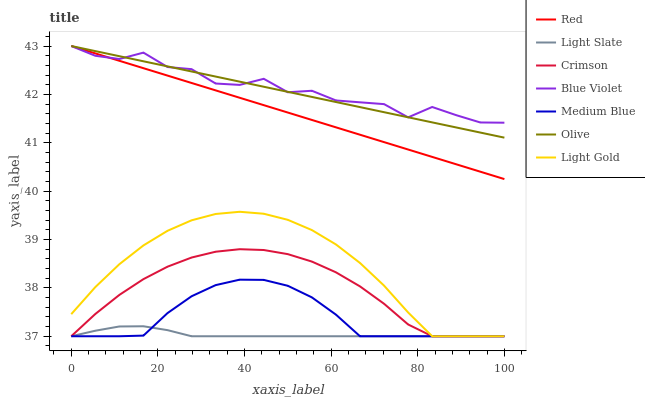Does Light Slate have the minimum area under the curve?
Answer yes or no. Yes. Does Blue Violet have the maximum area under the curve?
Answer yes or no. Yes. Does Medium Blue have the minimum area under the curve?
Answer yes or no. No. Does Medium Blue have the maximum area under the curve?
Answer yes or no. No. Is Olive the smoothest?
Answer yes or no. Yes. Is Blue Violet the roughest?
Answer yes or no. Yes. Is Medium Blue the smoothest?
Answer yes or no. No. Is Medium Blue the roughest?
Answer yes or no. No. Does Light Slate have the lowest value?
Answer yes or no. Yes. Does Olive have the lowest value?
Answer yes or no. No. Does Blue Violet have the highest value?
Answer yes or no. Yes. Does Medium Blue have the highest value?
Answer yes or no. No. Is Medium Blue less than Red?
Answer yes or no. Yes. Is Blue Violet greater than Crimson?
Answer yes or no. Yes. Does Light Gold intersect Light Slate?
Answer yes or no. Yes. Is Light Gold less than Light Slate?
Answer yes or no. No. Is Light Gold greater than Light Slate?
Answer yes or no. No. Does Medium Blue intersect Red?
Answer yes or no. No. 